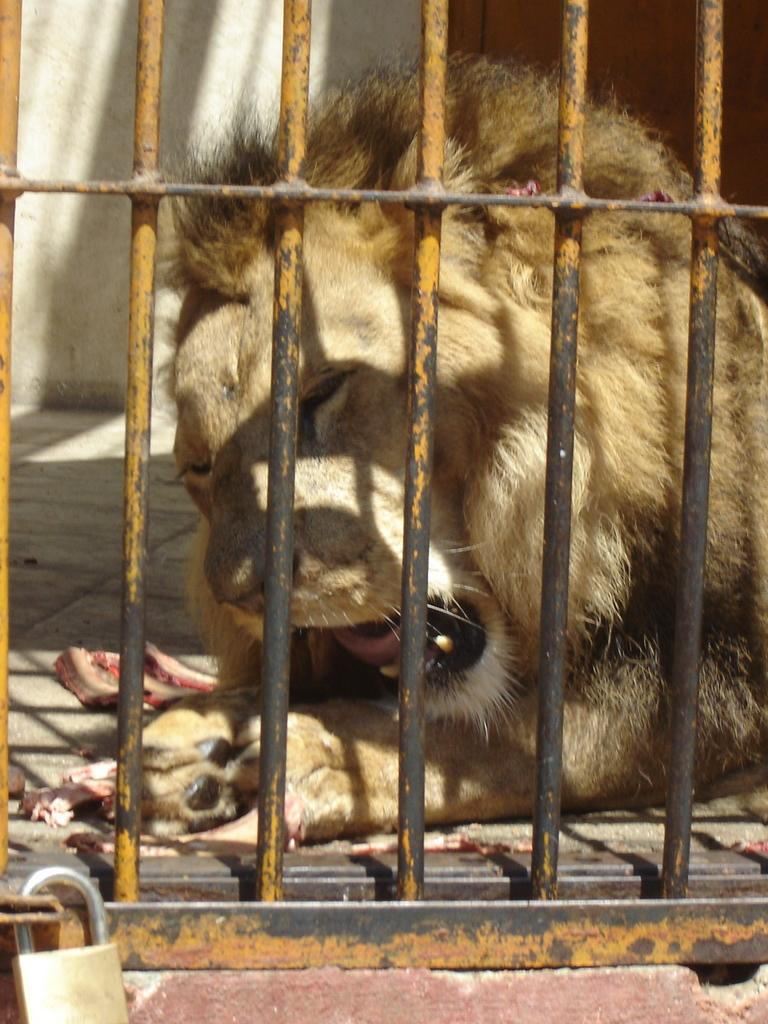What is present in the image that contains an animal? There is a cage in the image. What feature does the cage have to prevent the animal from escaping? The cage has a lock. What type of animal is inside the cage? There is a lion inside the cage. What color is the lion in the image? The lion is brown in color. Who is the expert in the image that helps with the selection of the lion? There is no expert present in the image, and the selection of the lion is not mentioned. 